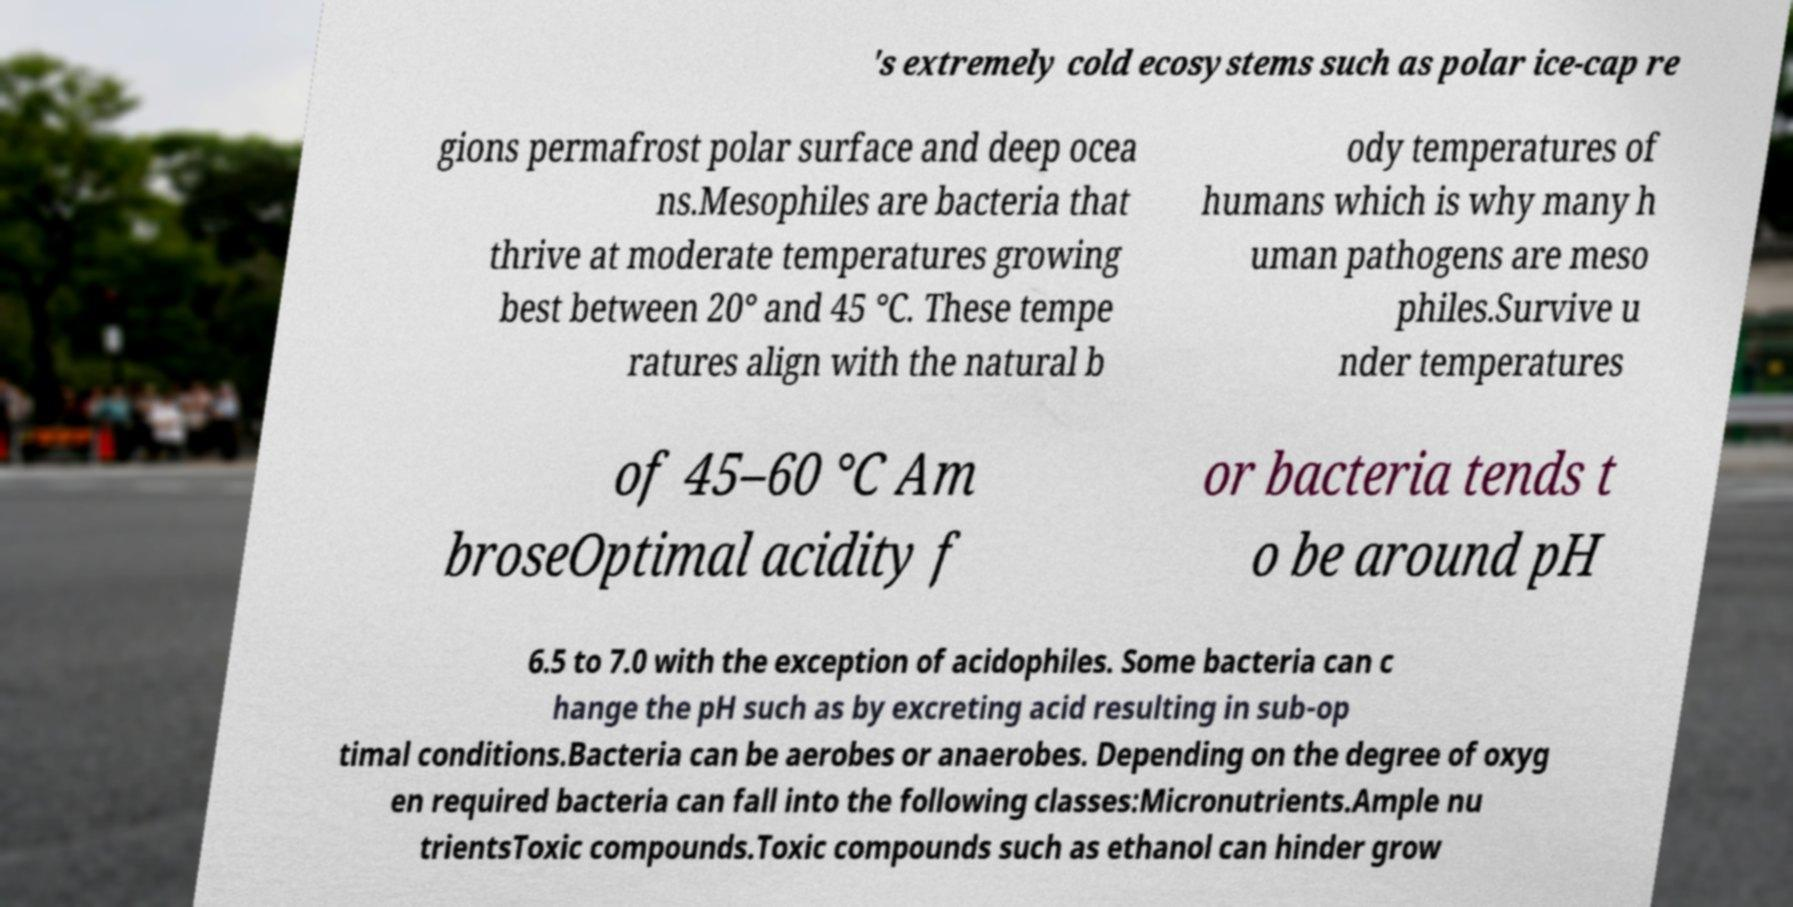Can you accurately transcribe the text from the provided image for me? 's extremely cold ecosystems such as polar ice-cap re gions permafrost polar surface and deep ocea ns.Mesophiles are bacteria that thrive at moderate temperatures growing best between 20° and 45 °C. These tempe ratures align with the natural b ody temperatures of humans which is why many h uman pathogens are meso philes.Survive u nder temperatures of 45–60 °C Am broseOptimal acidity f or bacteria tends t o be around pH 6.5 to 7.0 with the exception of acidophiles. Some bacteria can c hange the pH such as by excreting acid resulting in sub-op timal conditions.Bacteria can be aerobes or anaerobes. Depending on the degree of oxyg en required bacteria can fall into the following classes:Micronutrients.Ample nu trientsToxic compounds.Toxic compounds such as ethanol can hinder grow 